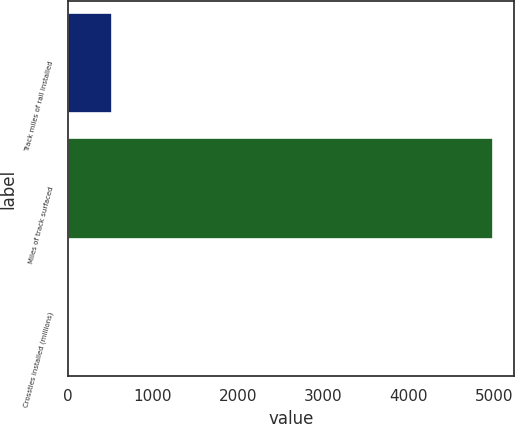Convert chart to OTSL. <chart><loc_0><loc_0><loc_500><loc_500><bar_chart><fcel>Track miles of rail installed<fcel>Miles of track surfaced<fcel>Crossties installed (millions)<nl><fcel>518<fcel>4984<fcel>2.3<nl></chart> 